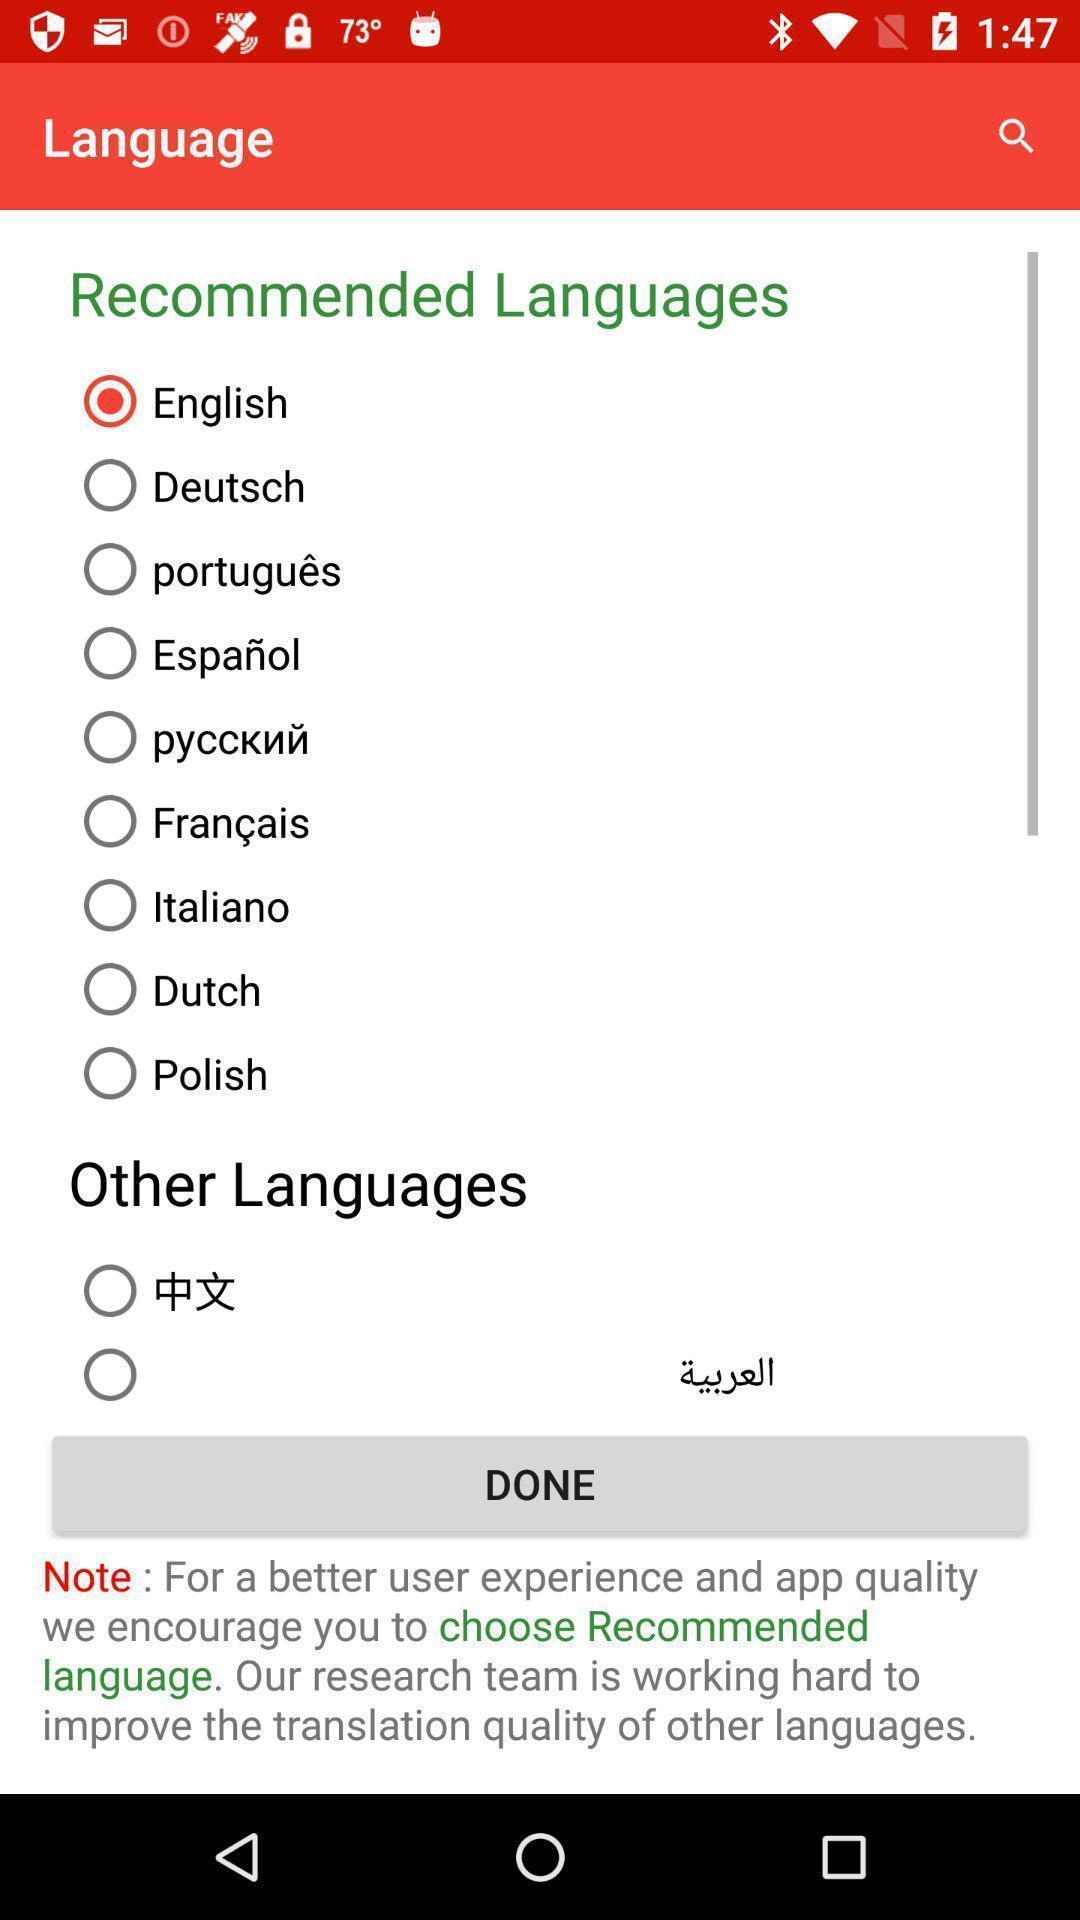What details can you identify in this image? Page showing the options for language selection. 